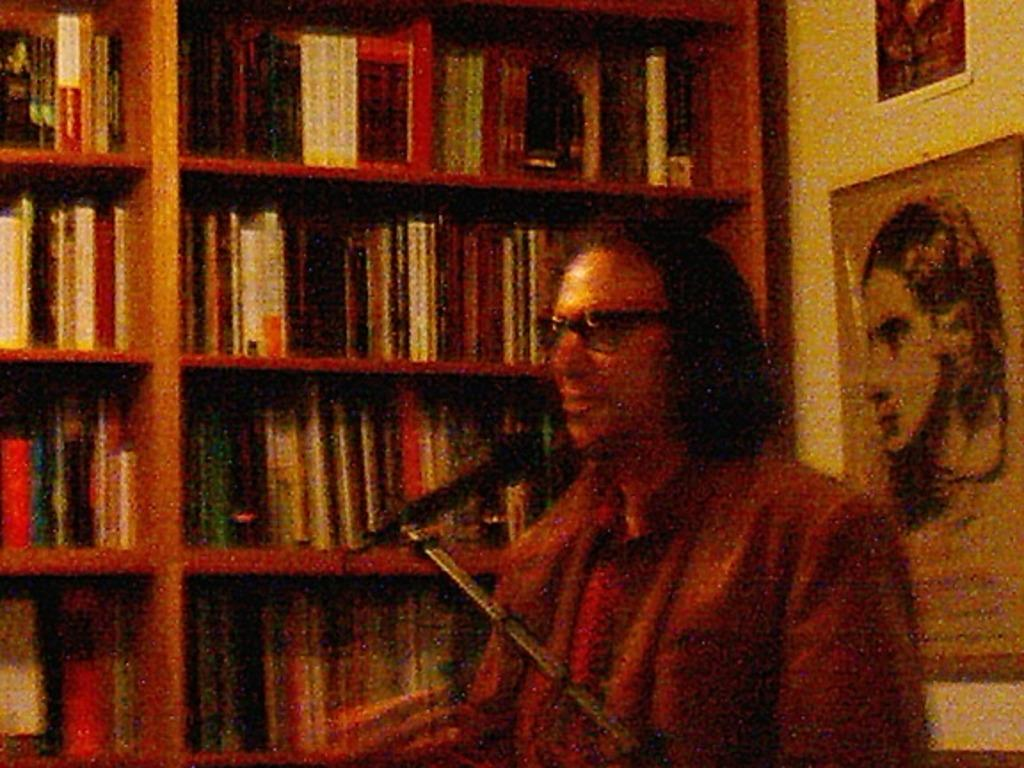<image>
Write a terse but informative summary of the picture. A man with glasses talking into a microphone in front of a book shelf. 